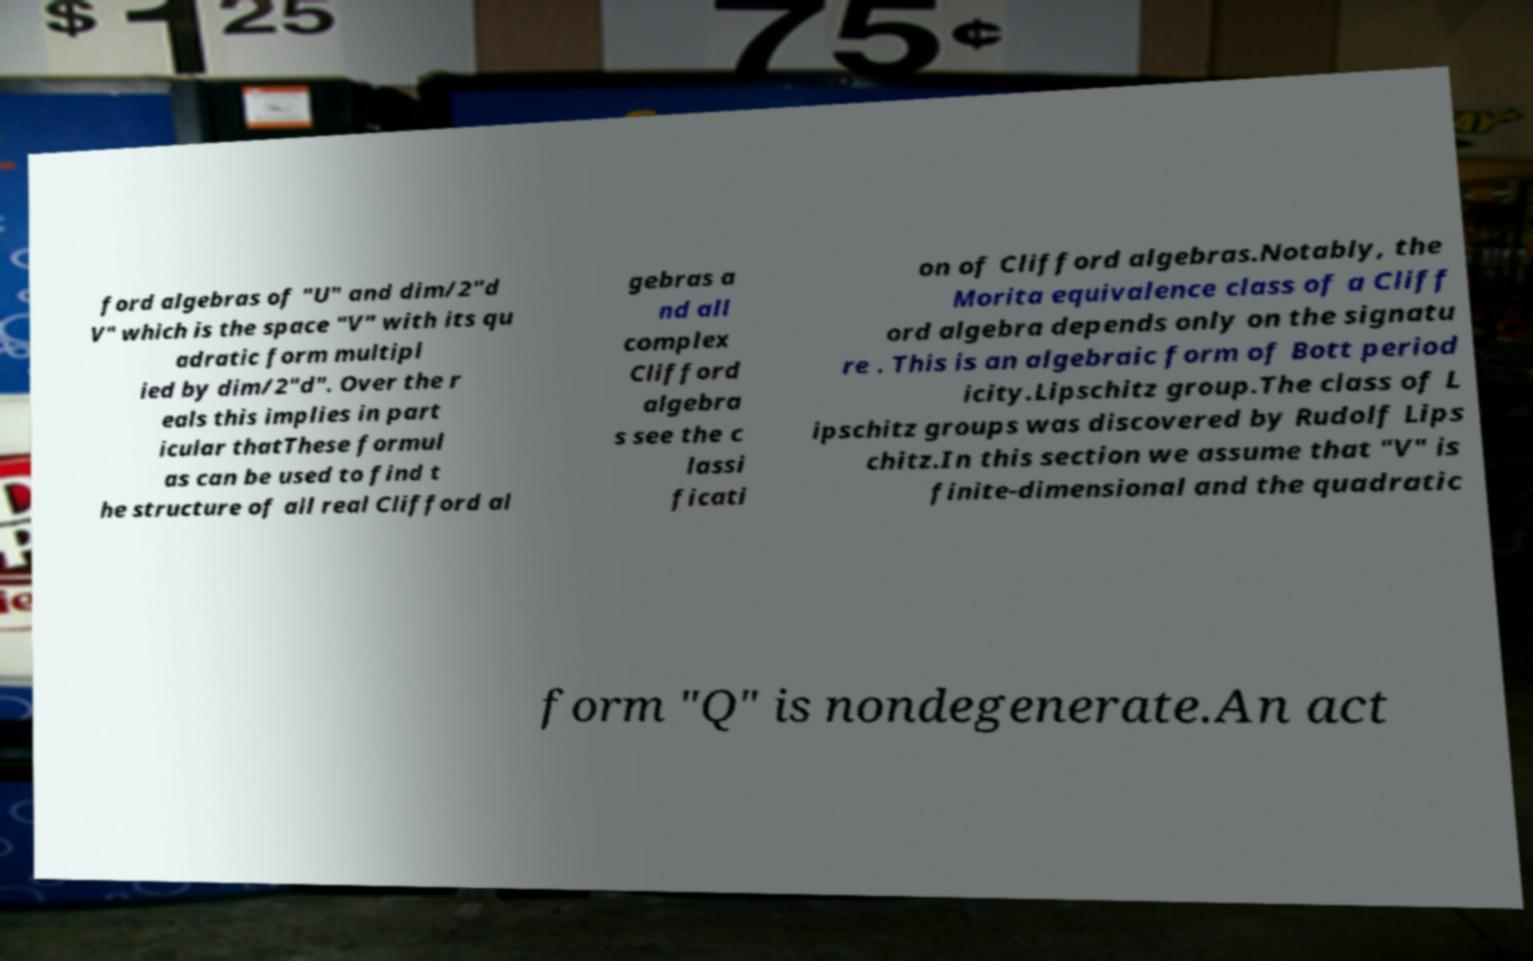I need the written content from this picture converted into text. Can you do that? ford algebras of "U" and dim/2"d V" which is the space "V" with its qu adratic form multipl ied by dim/2"d". Over the r eals this implies in part icular thatThese formul as can be used to find t he structure of all real Clifford al gebras a nd all complex Clifford algebra s see the c lassi ficati on of Clifford algebras.Notably, the Morita equivalence class of a Cliff ord algebra depends only on the signatu re . This is an algebraic form of Bott period icity.Lipschitz group.The class of L ipschitz groups was discovered by Rudolf Lips chitz.In this section we assume that "V" is finite-dimensional and the quadratic form "Q" is nondegenerate.An act 